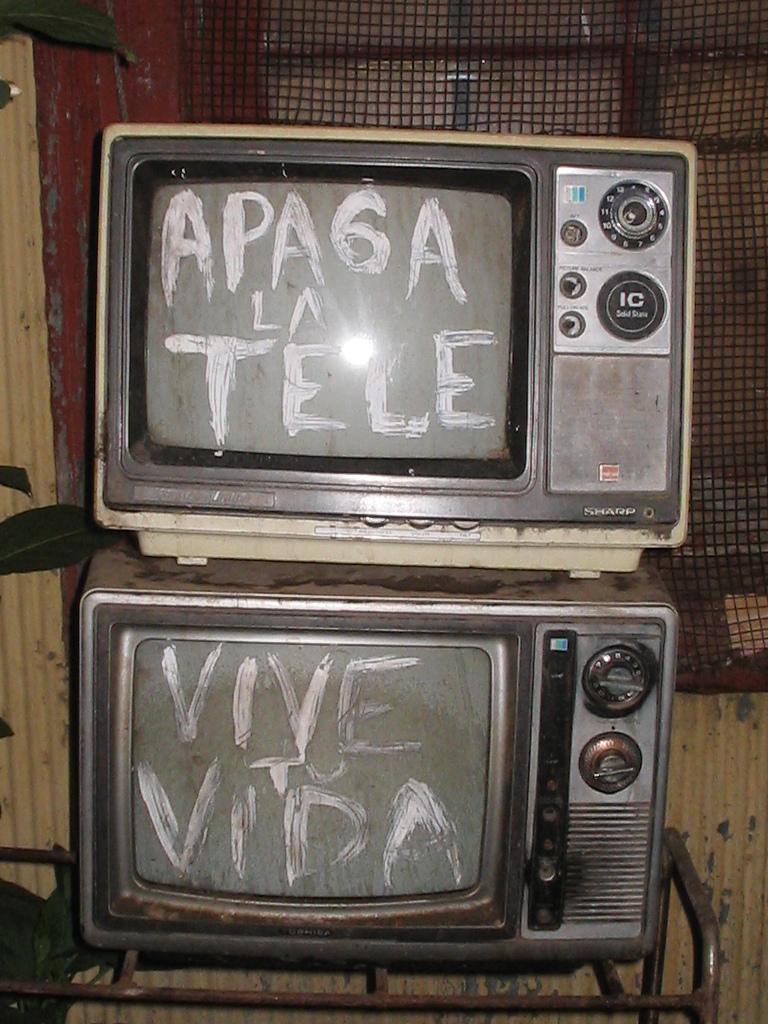What does the bottom tele say?
Offer a very short reply. Vive tu vida. What is written on the bottom screen?
Provide a succinct answer. Vive to vida. 